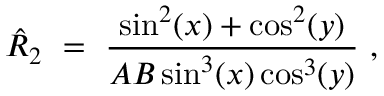Convert formula to latex. <formula><loc_0><loc_0><loc_500><loc_500>\hat { R } _ { 2 } \ = \ \frac { \sin ^ { 2 } ( x ) + \cos ^ { 2 } ( y ) } { A B \sin ^ { 3 } ( x ) \cos ^ { 3 } ( y ) } ,</formula> 